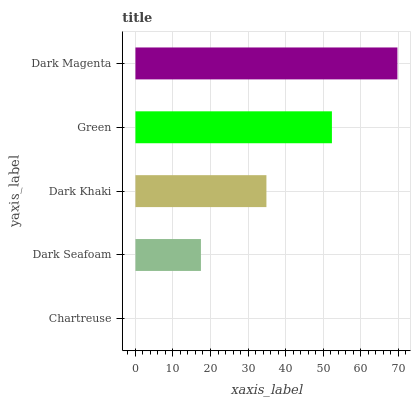Is Chartreuse the minimum?
Answer yes or no. Yes. Is Dark Magenta the maximum?
Answer yes or no. Yes. Is Dark Seafoam the minimum?
Answer yes or no. No. Is Dark Seafoam the maximum?
Answer yes or no. No. Is Dark Seafoam greater than Chartreuse?
Answer yes or no. Yes. Is Chartreuse less than Dark Seafoam?
Answer yes or no. Yes. Is Chartreuse greater than Dark Seafoam?
Answer yes or no. No. Is Dark Seafoam less than Chartreuse?
Answer yes or no. No. Is Dark Khaki the high median?
Answer yes or no. Yes. Is Dark Khaki the low median?
Answer yes or no. Yes. Is Green the high median?
Answer yes or no. No. Is Green the low median?
Answer yes or no. No. 